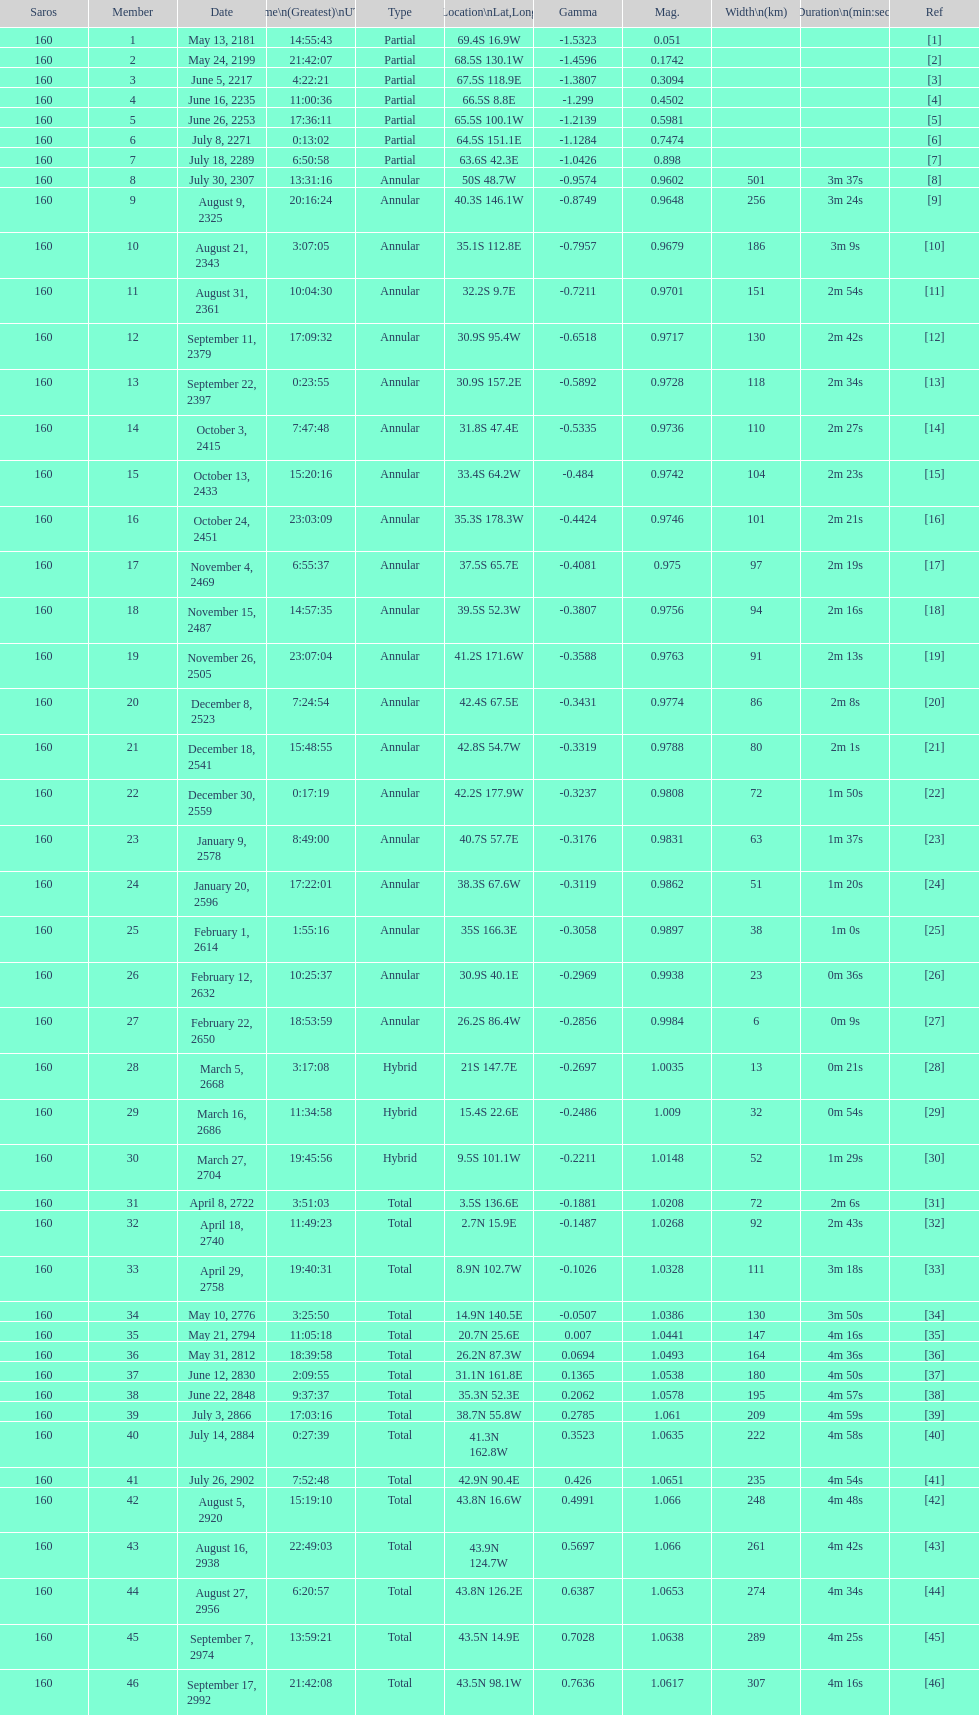Name a member number with a latitude above 60 s. 1. 